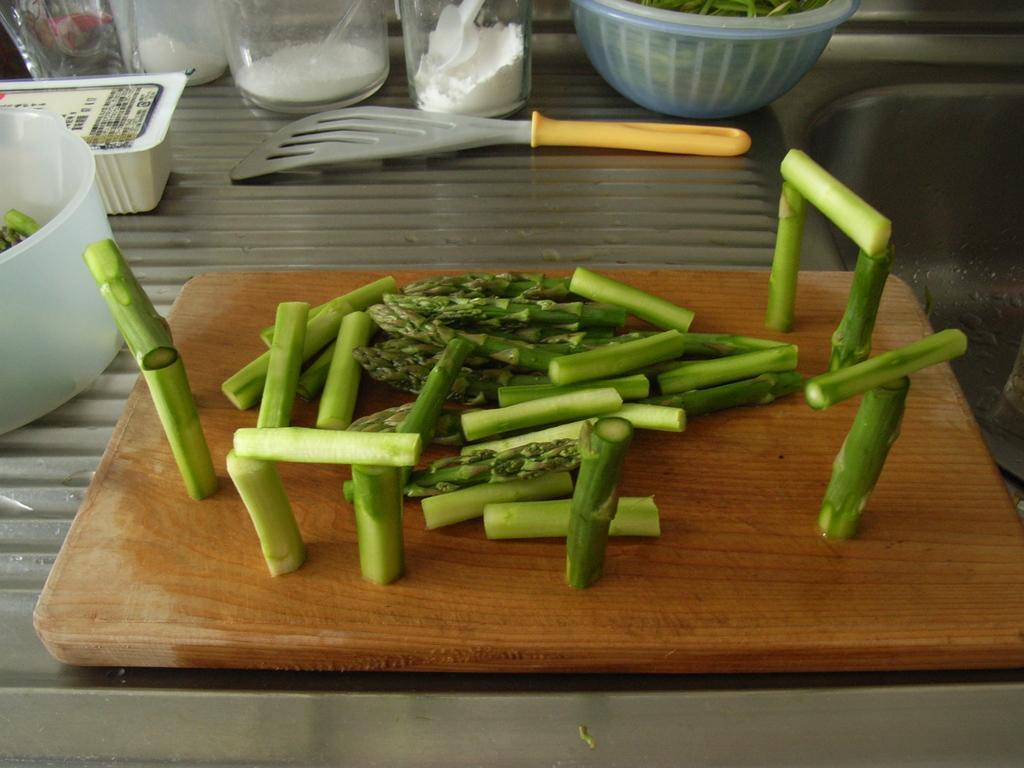Could you give a brief overview of what you see in this image? In the image there are some chopped vegetables on a chopping pad and beside that there are some bottles and bowls kept on a steel surface. 